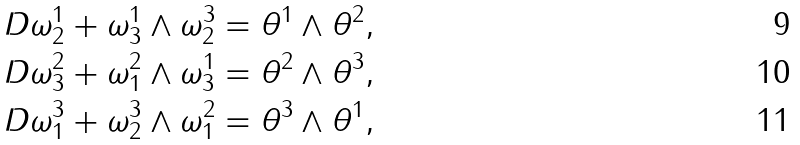Convert formula to latex. <formula><loc_0><loc_0><loc_500><loc_500>\ D \omega _ { 2 } ^ { 1 } + \omega _ { 3 } ^ { 1 } \land \omega _ { 2 } ^ { 3 } & = \theta ^ { 1 } \land \theta ^ { 2 } , \\ \ D \omega _ { 3 } ^ { 2 } + \omega _ { 1 } ^ { 2 } \land \omega _ { 3 } ^ { 1 } & = \theta ^ { 2 } \land \theta ^ { 3 } , \\ \ D \omega _ { 1 } ^ { 3 } + \omega _ { 2 } ^ { 3 } \land \omega _ { 1 } ^ { 2 } & = \theta ^ { 3 } \land \theta ^ { 1 } ,</formula> 